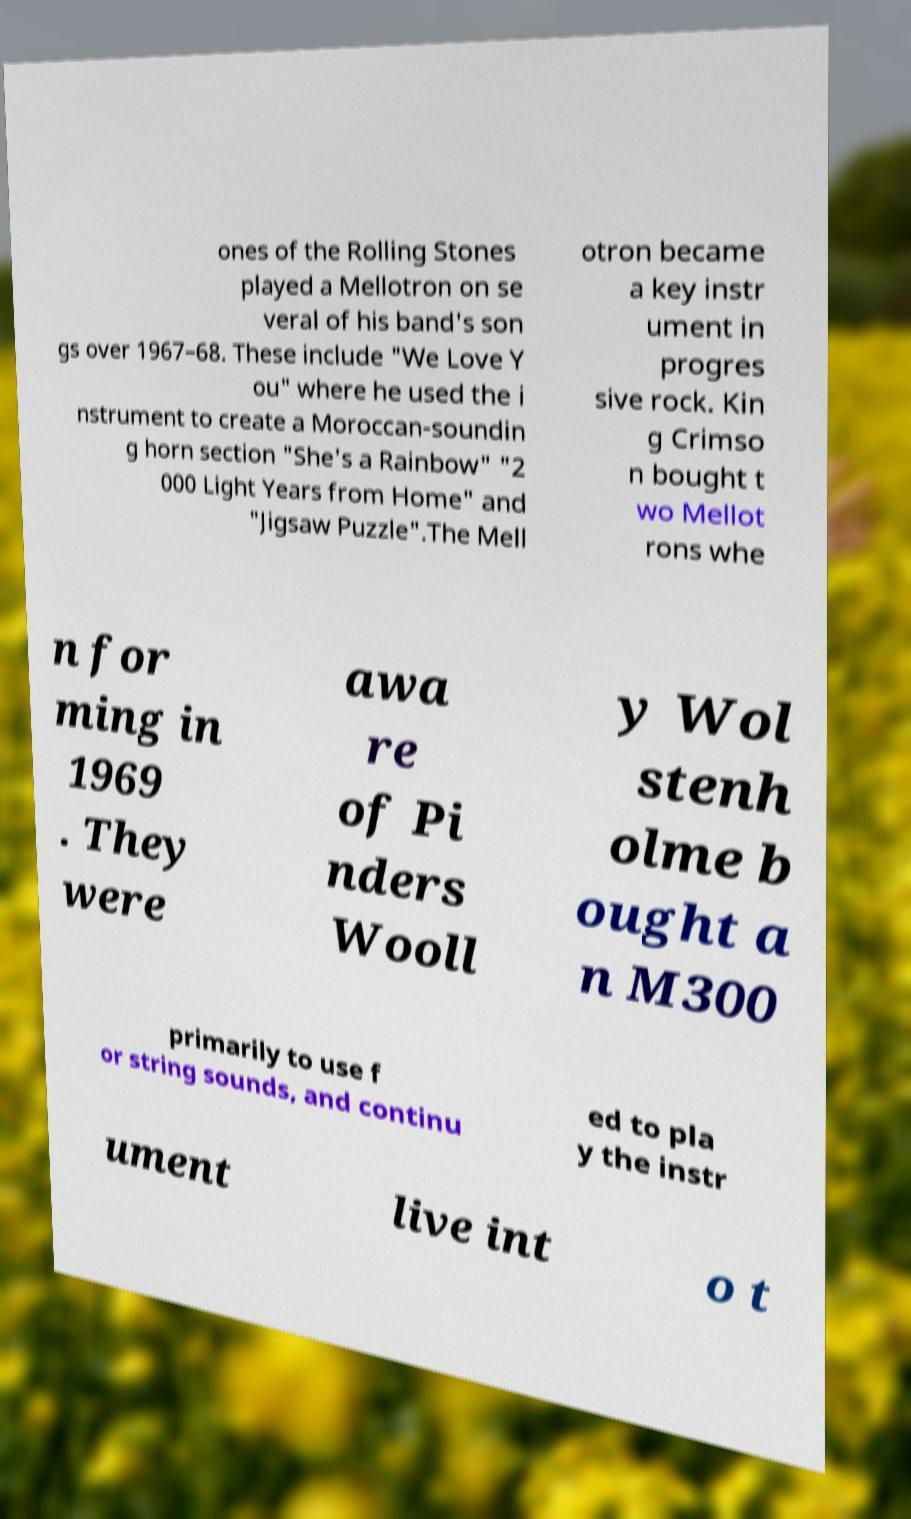I need the written content from this picture converted into text. Can you do that? ones of the Rolling Stones played a Mellotron on se veral of his band's son gs over 1967–68. These include "We Love Y ou" where he used the i nstrument to create a Moroccan-soundin g horn section "She's a Rainbow" "2 000 Light Years from Home" and "Jigsaw Puzzle".The Mell otron became a key instr ument in progres sive rock. Kin g Crimso n bought t wo Mellot rons whe n for ming in 1969 . They were awa re of Pi nders Wooll y Wol stenh olme b ought a n M300 primarily to use f or string sounds, and continu ed to pla y the instr ument live int o t 